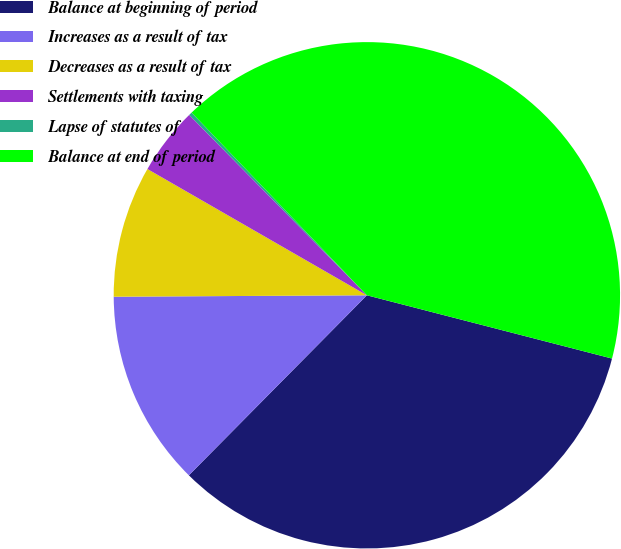Convert chart to OTSL. <chart><loc_0><loc_0><loc_500><loc_500><pie_chart><fcel>Balance at beginning of period<fcel>Increases as a result of tax<fcel>Decreases as a result of tax<fcel>Settlements with taxing<fcel>Lapse of statutes of<fcel>Balance at end of period<nl><fcel>33.39%<fcel>12.5%<fcel>8.4%<fcel>4.31%<fcel>0.21%<fcel>41.19%<nl></chart> 